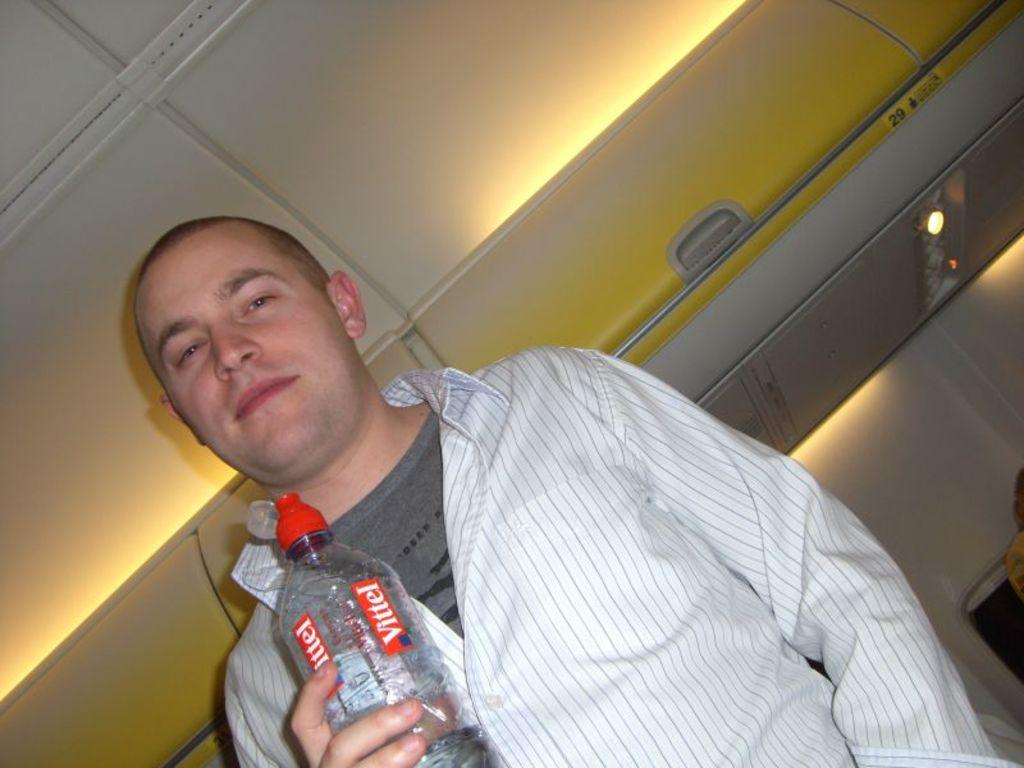What is the main subject of the image? There is a person in the image. What is the person doing in the image? The person is standing and holding a bottle. What can be seen in the background of the image? There is a box or luggage carrier in the background of the image. How is the person's mood depicted in the image? The person is smiling in the image. What type of egg is being used in the machine depicted in the image? There is no machine or egg present in the image. What sound does the horn make in the image? There is no horn present in the image. 